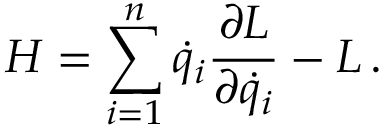Convert formula to latex. <formula><loc_0><loc_0><loc_500><loc_500>H = \sum _ { i = 1 } ^ { n } { \dot { q } } _ { i } { \frac { \partial L } { \partial { \dot { q } } _ { i } } } - L \, .</formula> 